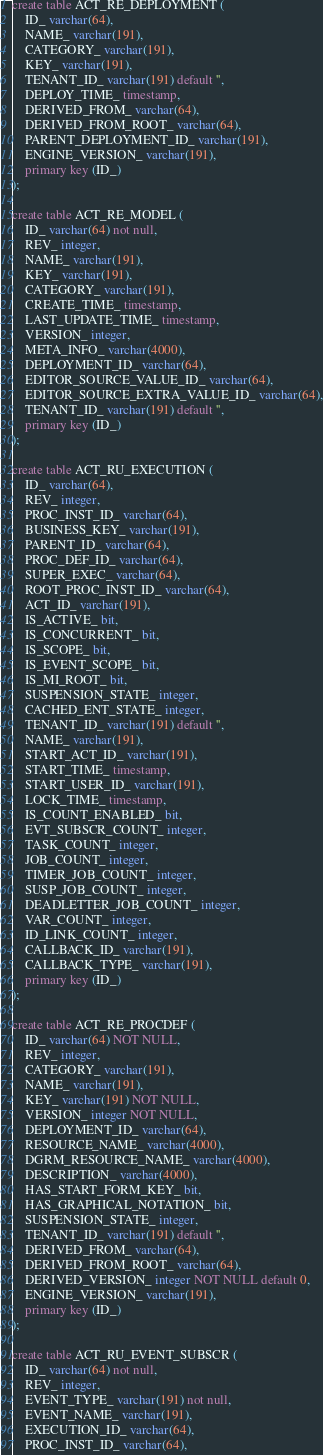Convert code to text. <code><loc_0><loc_0><loc_500><loc_500><_SQL_>create table ACT_RE_DEPLOYMENT (
    ID_ varchar(64),
    NAME_ varchar(191),
    CATEGORY_ varchar(191),
    KEY_ varchar(191),
    TENANT_ID_ varchar(191) default '',
    DEPLOY_TIME_ timestamp,
    DERIVED_FROM_ varchar(64),
    DERIVED_FROM_ROOT_ varchar(64),
    PARENT_DEPLOYMENT_ID_ varchar(191),
    ENGINE_VERSION_ varchar(191),
    primary key (ID_)
);

create table ACT_RE_MODEL (
    ID_ varchar(64) not null,
    REV_ integer,
    NAME_ varchar(191),
    KEY_ varchar(191),
    CATEGORY_ varchar(191),
    CREATE_TIME_ timestamp,
    LAST_UPDATE_TIME_ timestamp,
    VERSION_ integer,
    META_INFO_ varchar(4000),
    DEPLOYMENT_ID_ varchar(64),
    EDITOR_SOURCE_VALUE_ID_ varchar(64),
    EDITOR_SOURCE_EXTRA_VALUE_ID_ varchar(64),
    TENANT_ID_ varchar(191) default '',
    primary key (ID_)
);

create table ACT_RU_EXECUTION (
    ID_ varchar(64),
    REV_ integer,
    PROC_INST_ID_ varchar(64),
    BUSINESS_KEY_ varchar(191),
    PARENT_ID_ varchar(64),
    PROC_DEF_ID_ varchar(64),
    SUPER_EXEC_ varchar(64),
    ROOT_PROC_INST_ID_ varchar(64),
    ACT_ID_ varchar(191),
    IS_ACTIVE_ bit,
    IS_CONCURRENT_ bit,
    IS_SCOPE_ bit,
    IS_EVENT_SCOPE_ bit,
    IS_MI_ROOT_ bit,
    SUSPENSION_STATE_ integer,
    CACHED_ENT_STATE_ integer,
    TENANT_ID_ varchar(191) default '',
    NAME_ varchar(191),
    START_ACT_ID_ varchar(191),
    START_TIME_ timestamp,
    START_USER_ID_ varchar(191),
    LOCK_TIME_ timestamp,
    IS_COUNT_ENABLED_ bit,
    EVT_SUBSCR_COUNT_ integer, 
    TASK_COUNT_ integer, 
    JOB_COUNT_ integer, 
    TIMER_JOB_COUNT_ integer,
    SUSP_JOB_COUNT_ integer,
    DEADLETTER_JOB_COUNT_ integer,
    VAR_COUNT_ integer, 
    ID_LINK_COUNT_ integer,
    CALLBACK_ID_ varchar(191),
    CALLBACK_TYPE_ varchar(191),
    primary key (ID_)
);

create table ACT_RE_PROCDEF (
    ID_ varchar(64) NOT NULL,
    REV_ integer,
    CATEGORY_ varchar(191),
    NAME_ varchar(191),
    KEY_ varchar(191) NOT NULL,
    VERSION_ integer NOT NULL,
    DEPLOYMENT_ID_ varchar(64),
    RESOURCE_NAME_ varchar(4000),
    DGRM_RESOURCE_NAME_ varchar(4000),
    DESCRIPTION_ varchar(4000),
    HAS_START_FORM_KEY_ bit,
    HAS_GRAPHICAL_NOTATION_ bit,
    SUSPENSION_STATE_ integer,
    TENANT_ID_ varchar(191) default '',
    DERIVED_FROM_ varchar(64),
    DERIVED_FROM_ROOT_ varchar(64),
    DERIVED_VERSION_ integer NOT NULL default 0,
    ENGINE_VERSION_ varchar(191),
    primary key (ID_)
);

create table ACT_RU_EVENT_SUBSCR (
    ID_ varchar(64) not null,
    REV_ integer,
    EVENT_TYPE_ varchar(191) not null,
    EVENT_NAME_ varchar(191),
    EXECUTION_ID_ varchar(64),
    PROC_INST_ID_ varchar(64),</code> 